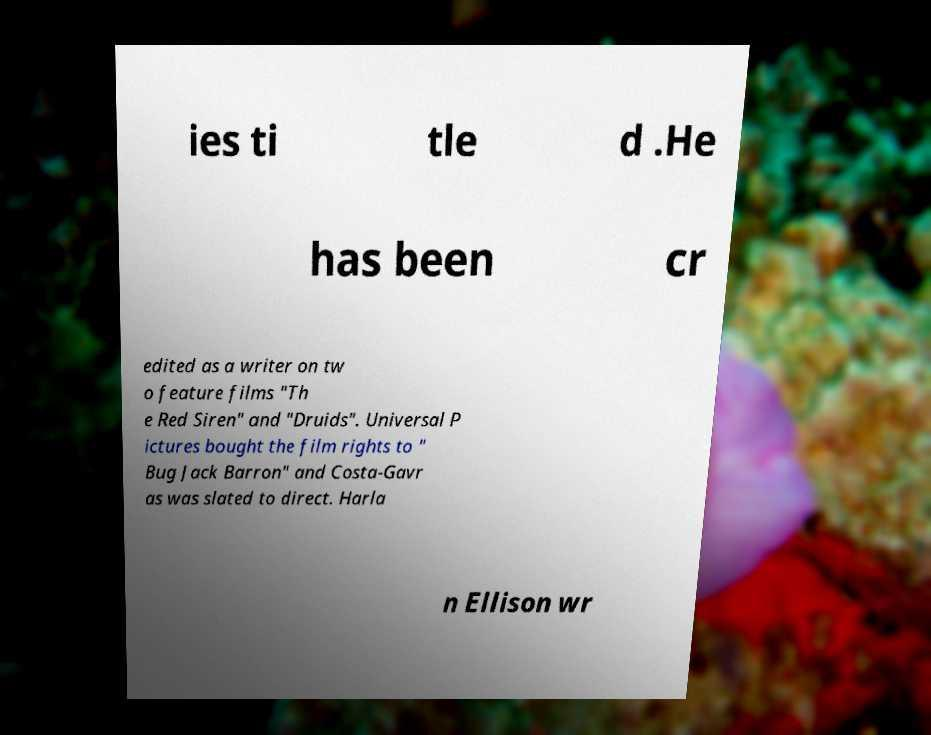There's text embedded in this image that I need extracted. Can you transcribe it verbatim? ies ti tle d .He has been cr edited as a writer on tw o feature films "Th e Red Siren" and "Druids". Universal P ictures bought the film rights to " Bug Jack Barron" and Costa-Gavr as was slated to direct. Harla n Ellison wr 